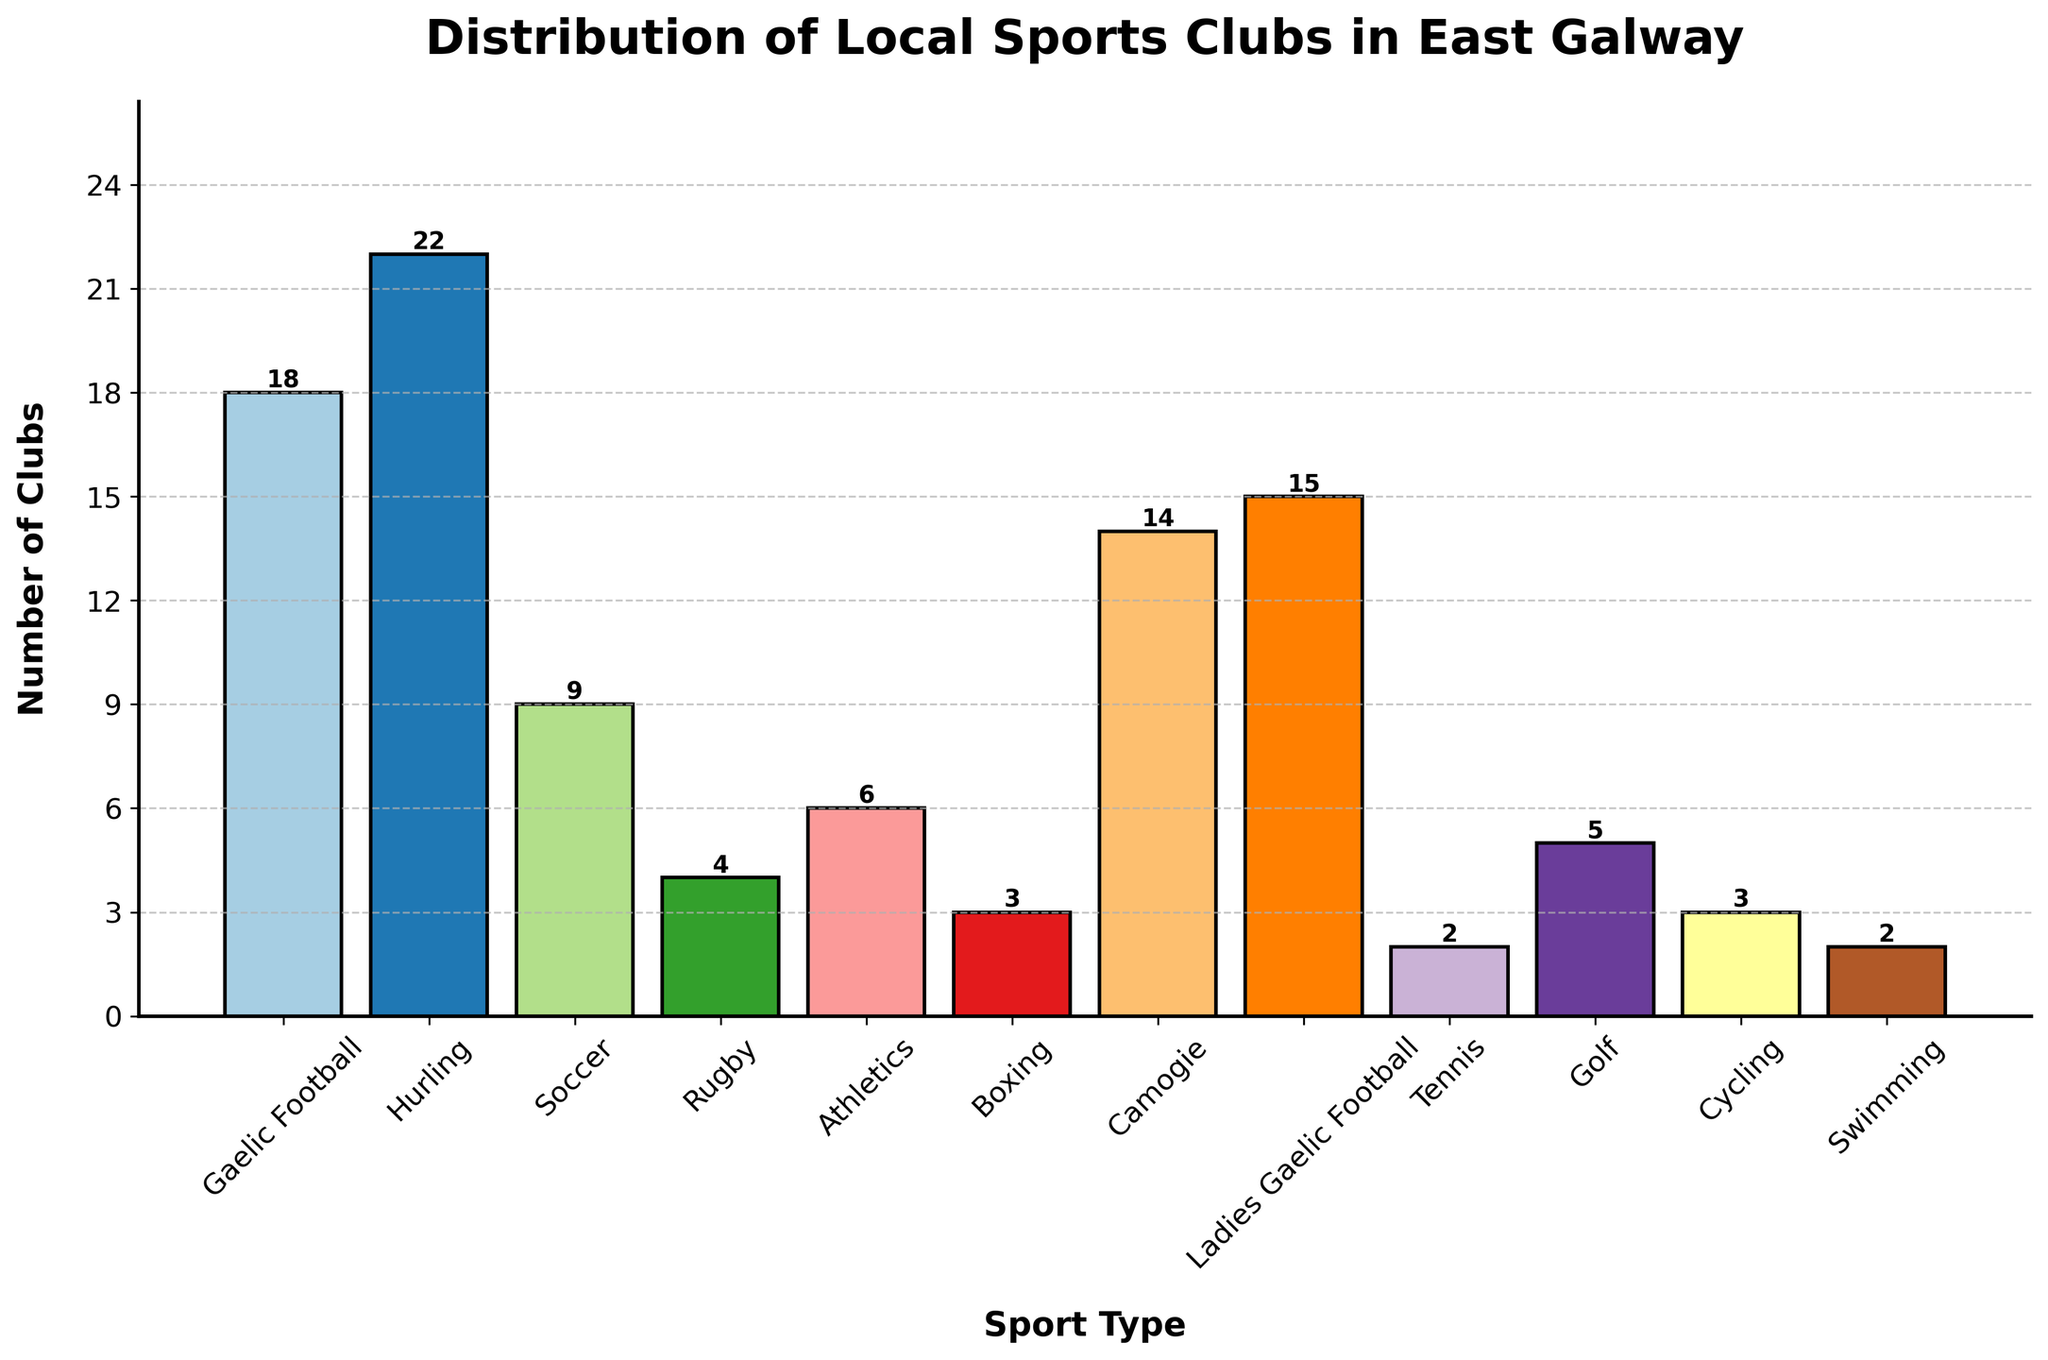What sport type has the highest number of clubs? The bar corresponding to Hurling reaches the highest point on the y-axis, indicating it has the most clubs.
Answer: Hurling Which type of sport has more clubs: Soccer or Rugby? Compare the heights of the bars for Soccer and Rugby; the Soccer bar is higher.
Answer: Soccer How many more Camogie clubs are there than Athletics clubs? Find the heights of the Camogie and Athletics bars (14 and 6 respectively) and subtract Athletics from Camogie (14 - 6).
Answer: 8 What is the total number of clubs for Gaelic Football and Ladies Gaelic Football combined? Add the number of clubs for Gaelic Football (18) and Ladies Gaelic Football (15).
Answer: 33 What is the difference in the number of clubs between the sport with the least clubs and the sport with the most clubs? Identify the sport with the most clubs (Hurling, 22) and the sport with the least clubs (Tennis and Swimming, both 2), then subtract the smallest value from the largest (22 - 2).
Answer: 20 Between Athletics and Boxing, which sport type has more clubs and by how much? Compare the number of clubs for Athletics (6) and Boxing (3); subtract Boxing from Athletics (6 - 3).
Answer: Athletics by 3 Which sports have the same number of clubs? Identify sports with identical bar heights: Cycling and Boxing both have 3 clubs, Tennis and Swimming each have 2 clubs.
Answer: Cycling and Boxing; Tennis and Swimming What is the average number of clubs across all sports types? Sum the number of clubs for all sports types and divide by the number of sports types: (18+22+9+4+6+3+14+15+2+5+3+2) / 12 = 103 / 12.
Answer: 8.58 How many clubs are there in total for all sports? Sum the number of clubs for each sport: 18+22+9+4+6+3+14+15+2+5+3+2.
Answer: 103 Which sport has the third highest number of clubs? Rank sports by the number of clubs and identify the third highest: Hurling (22), Gaelic Football (18), Ladies Gaelic Football (15).
Answer: Ladies Gaelic Football 